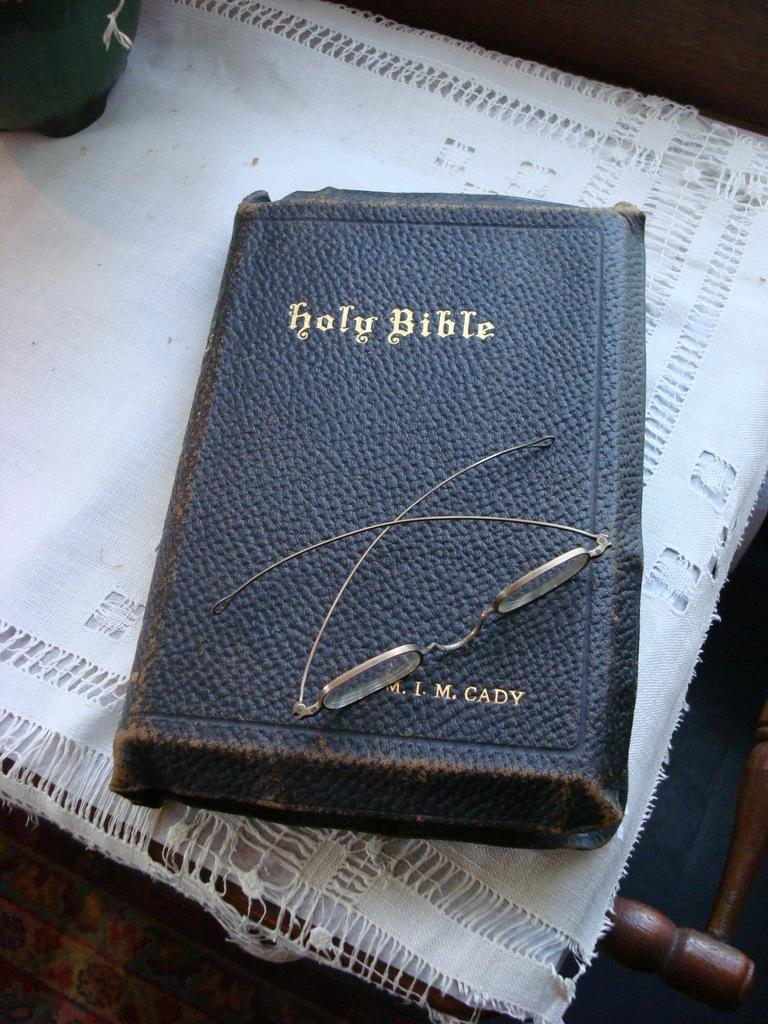What is the main object in the foreground of the picture? There is a bible in the foreground of the picture. What is placed on the bible? There are spectacles on the bible. On what surface are the bible and spectacles placed? The bible and spectacles are placed on a wooden object. What can be seen at the top left of the image? There is an object at the top left of the image. What type of fight is taking place on the stage in the image? There is no stage or fight present in the image; it features a bible with spectacles on a wooden object. Where can the pocket be found in the image? There is no pocket visible in the image. 